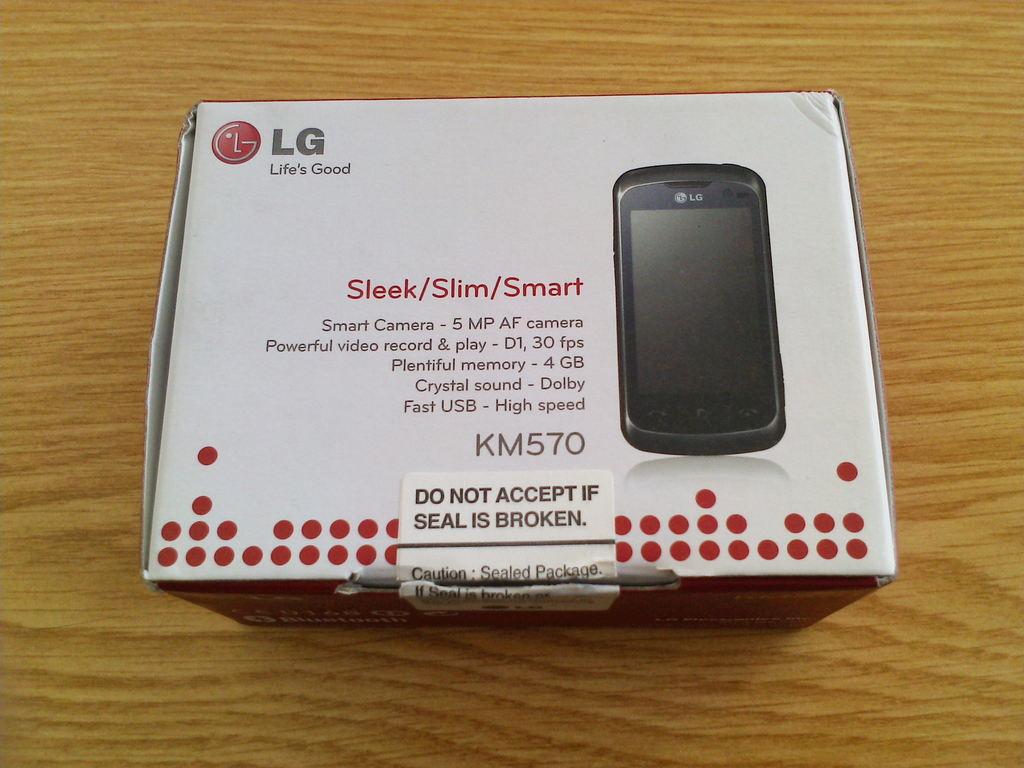Is the lg phone thin?
Make the answer very short. Yes. Is km570 the model number of that lg phone?
Make the answer very short. Yes. 